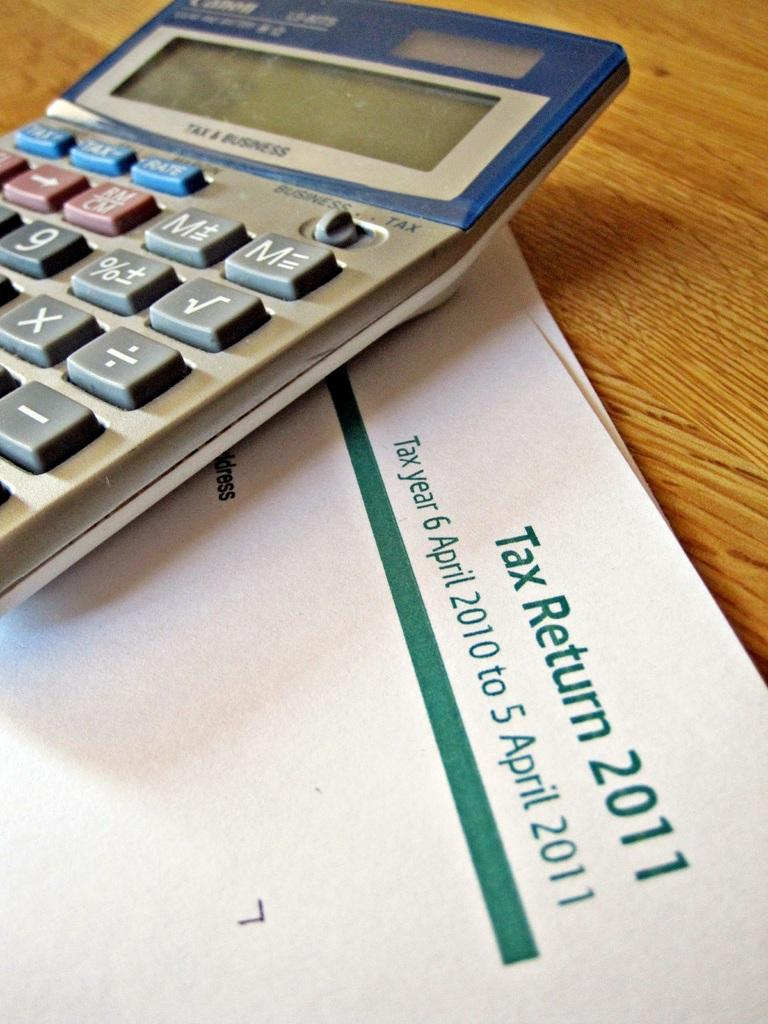<image>
Provide a brief description of the given image. A calculator and a 2011 tax return form. 